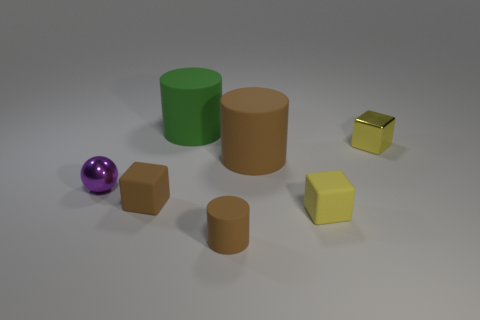Add 1 brown objects. How many objects exist? 8 Subtract all spheres. How many objects are left? 6 Subtract 0 green balls. How many objects are left? 7 Subtract all large red rubber blocks. Subtract all small purple objects. How many objects are left? 6 Add 1 brown matte cylinders. How many brown matte cylinders are left? 3 Add 5 tiny brown objects. How many tiny brown objects exist? 7 